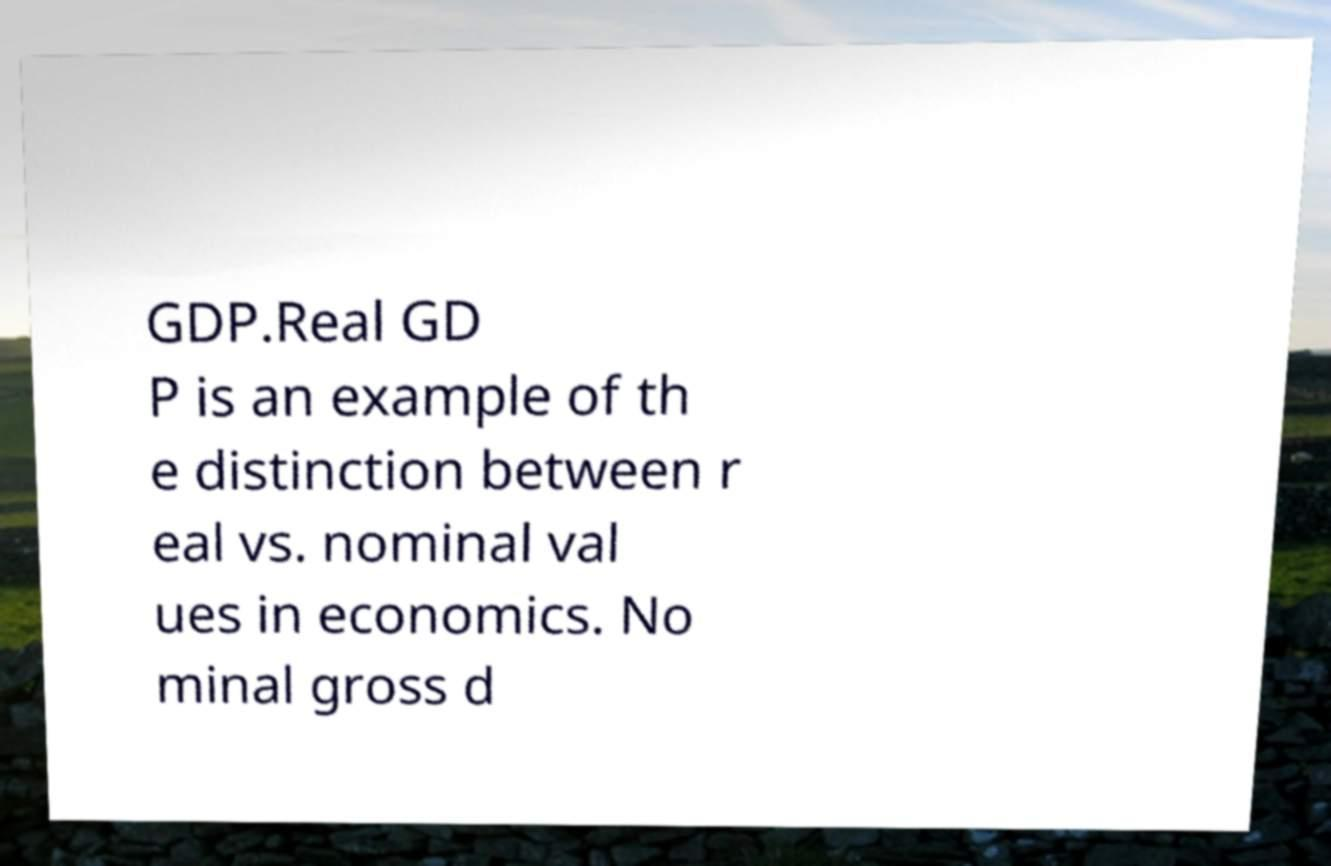Can you accurately transcribe the text from the provided image for me? GDP.Real GD P is an example of th e distinction between r eal vs. nominal val ues in economics. No minal gross d 